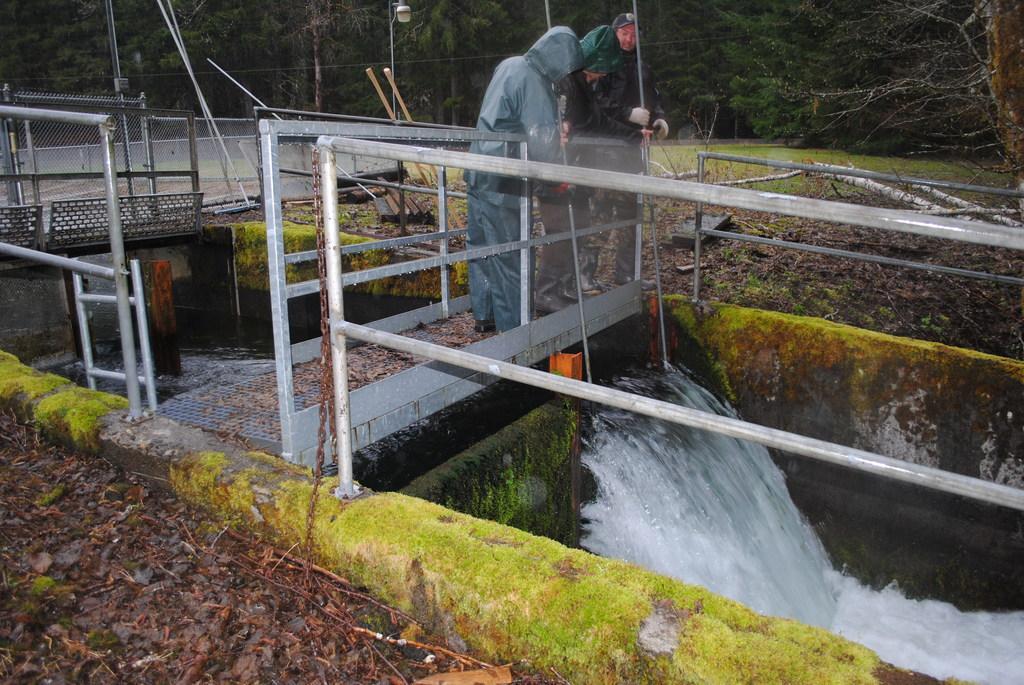Describe this image in one or two sentences. In this picture we can see two people are standing and holding sticks in their hands. There is water. There is some fencing from left to right. We can see a streetlight and a few trees in the background. 